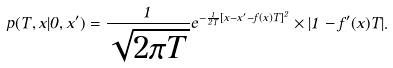Convert formula to latex. <formula><loc_0><loc_0><loc_500><loc_500>p ( T , x | 0 , x ^ { \prime } ) = \frac { 1 } { \sqrt { 2 \pi T } } e ^ { - \frac { 1 } { 2 T } [ x - x ^ { \prime } - f ( x ) T ] ^ { 2 } } \times | 1 - f ^ { \prime } ( x ) T | .</formula> 